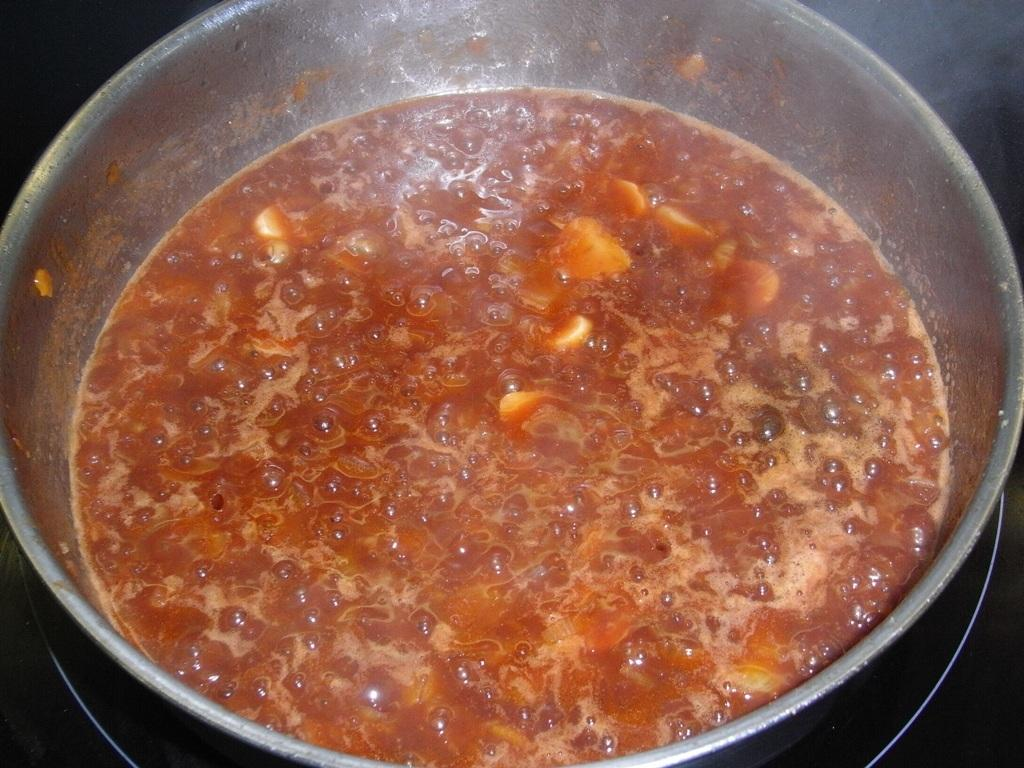What activity is taking place in the image? The image shows the preparation of food. In what type of container is the food being prepared? The food is being prepared in a vessel. How does the memory of the food being prepared affect the taste of the dish? The image does not provide any information about the memory of the food being prepared, so it cannot be determined how it might affect the taste of the dish. 